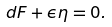Convert formula to latex. <formula><loc_0><loc_0><loc_500><loc_500>d F + \epsilon \eta = 0 .</formula> 